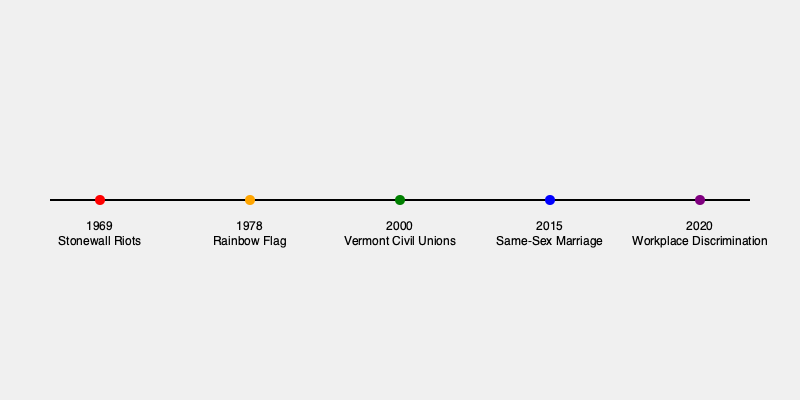Based on the timeline provided, which event marked a significant turning point for LGBTQ+ rights in the United States, often considered the birth of the modern LGBTQ+ rights movement? To answer this question, we need to analyze the events presented in the timeline:

1. 1969 - Stonewall Riots
2. 1978 - Creation of the Rainbow Flag
3. 2000 - Vermont Civil Unions
4. 2015 - Same-Sex Marriage Legalization
5. 2020 - Workplace Discrimination Protection

Among these events, the Stonewall Riots of 1969 are widely recognized as the catalyst for the modern LGBTQ+ rights movement in the United States. Here's why:

1. Historical context: The Stonewall Riots were a series of spontaneous demonstrations by members of the LGBTQ+ community against a police raid at the Stonewall Inn in New York City.

2. Timing: It was the earliest event on the timeline, marking the beginning of more visible and organized LGBTQ+ activism.

3. Impact: The riots led to the formation of numerous gay rights organizations and the first Pride marches.

4. Symbolic importance: Stonewall is often referred to as the "birth" of the modern LGBTQ+ rights movement, as it represented a shift from quiet acceptance to active resistance against discrimination.

5. Ongoing significance: The event is commemorated annually with Pride celebrations around the world.

While all the events on the timeline are significant milestones in LGBTQ+ rights, the Stonewall Riots stand out as the turning point that ignited the modern movement for equality and visibility.
Answer: Stonewall Riots (1969) 